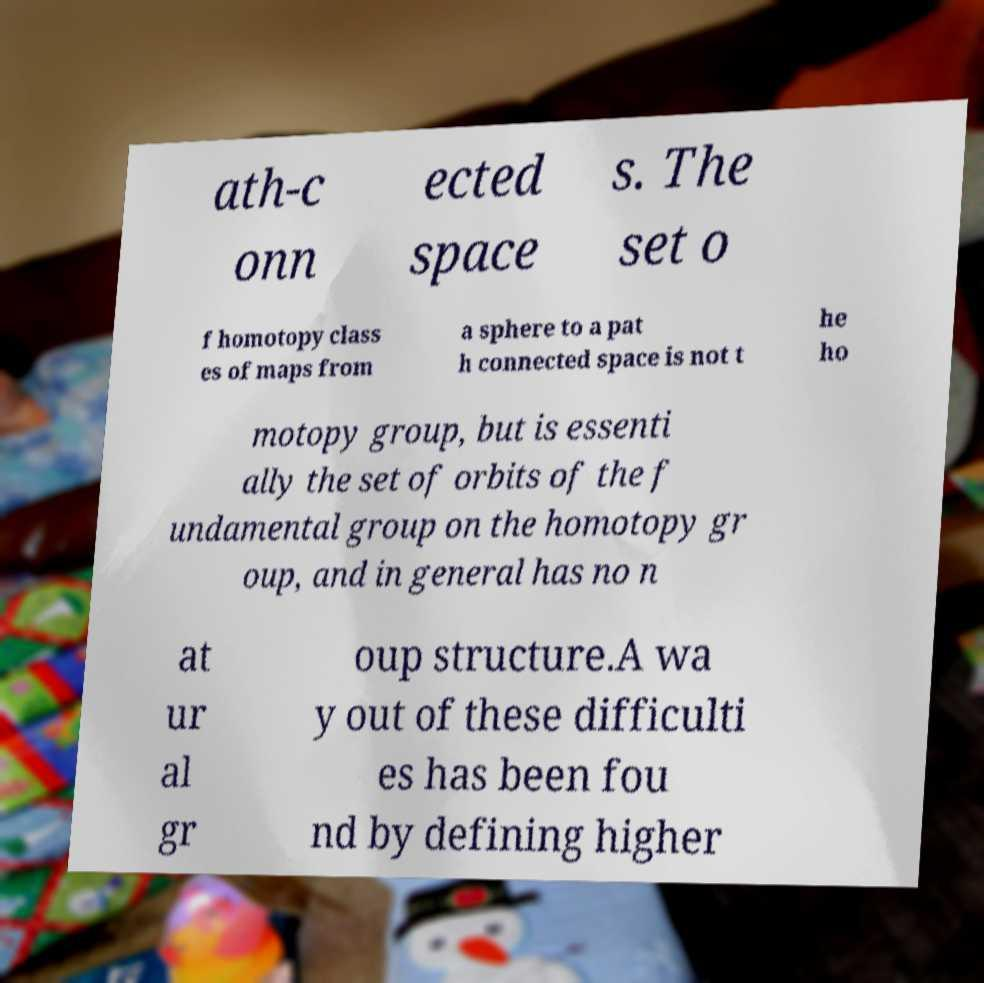Can you accurately transcribe the text from the provided image for me? ath-c onn ected space s. The set o f homotopy class es of maps from a sphere to a pat h connected space is not t he ho motopy group, but is essenti ally the set of orbits of the f undamental group on the homotopy gr oup, and in general has no n at ur al gr oup structure.A wa y out of these difficulti es has been fou nd by defining higher 